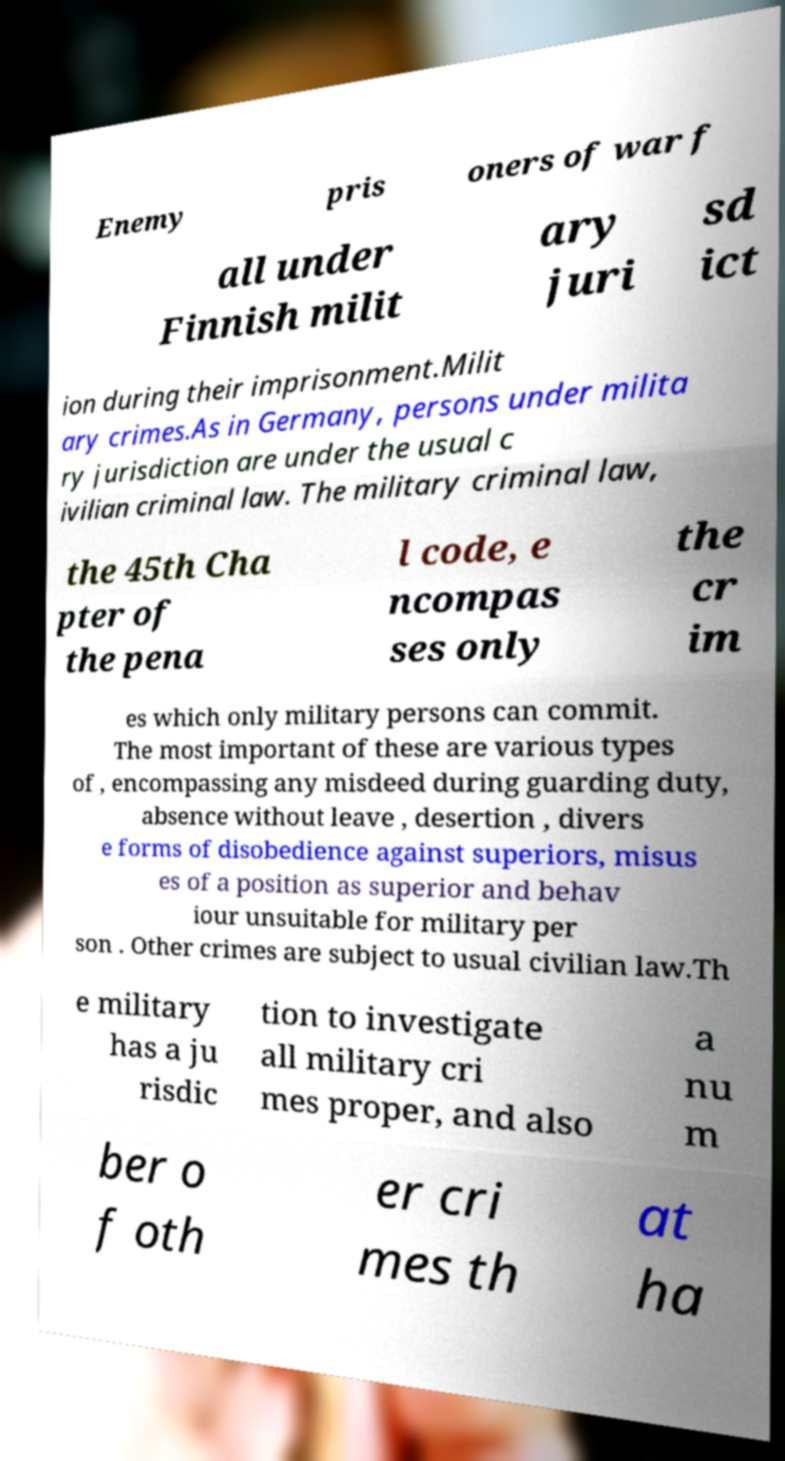I need the written content from this picture converted into text. Can you do that? Enemy pris oners of war f all under Finnish milit ary juri sd ict ion during their imprisonment.Milit ary crimes.As in Germany, persons under milita ry jurisdiction are under the usual c ivilian criminal law. The military criminal law, the 45th Cha pter of the pena l code, e ncompas ses only the cr im es which only military persons can commit. The most important of these are various types of , encompassing any misdeed during guarding duty, absence without leave , desertion , divers e forms of disobedience against superiors, misus es of a position as superior and behav iour unsuitable for military per son . Other crimes are subject to usual civilian law.Th e military has a ju risdic tion to investigate all military cri mes proper, and also a nu m ber o f oth er cri mes th at ha 